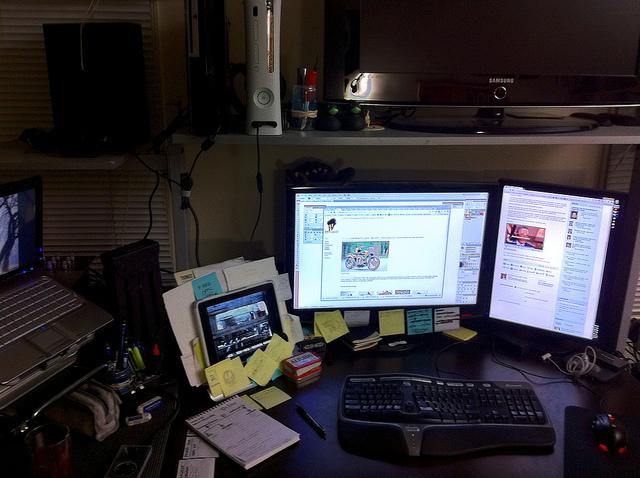How many monitors are seen?
Write a very short answer. 3. Is this a large desk?
Answer briefly. Yes. What color is the mousepad?
Keep it brief. Black. What is the yellow pieces of paper called?
Quick response, please. Post it notes. What is covering the windows?
Keep it brief. Blinds. Why are there so many computer monitors?
Short answer required. Multitasking. 